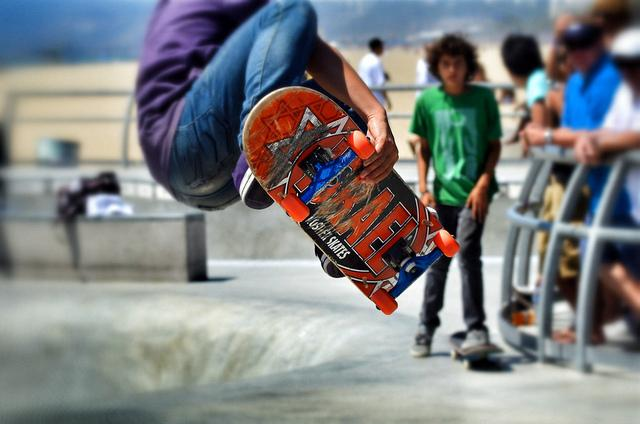Why is the boy wearing purple touching the bottom of the skateboard? performing tricks 